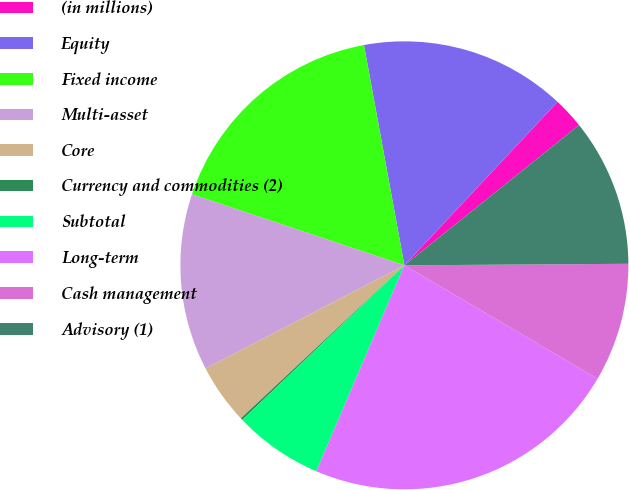Convert chart to OTSL. <chart><loc_0><loc_0><loc_500><loc_500><pie_chart><fcel>(in millions)<fcel>Equity<fcel>Fixed income<fcel>Multi-asset<fcel>Core<fcel>Currency and commodities (2)<fcel>Subtotal<fcel>Long-term<fcel>Cash management<fcel>Advisory (1)<nl><fcel>2.25%<fcel>14.87%<fcel>16.97%<fcel>12.76%<fcel>4.35%<fcel>0.15%<fcel>6.45%<fcel>22.98%<fcel>8.56%<fcel>10.66%<nl></chart> 